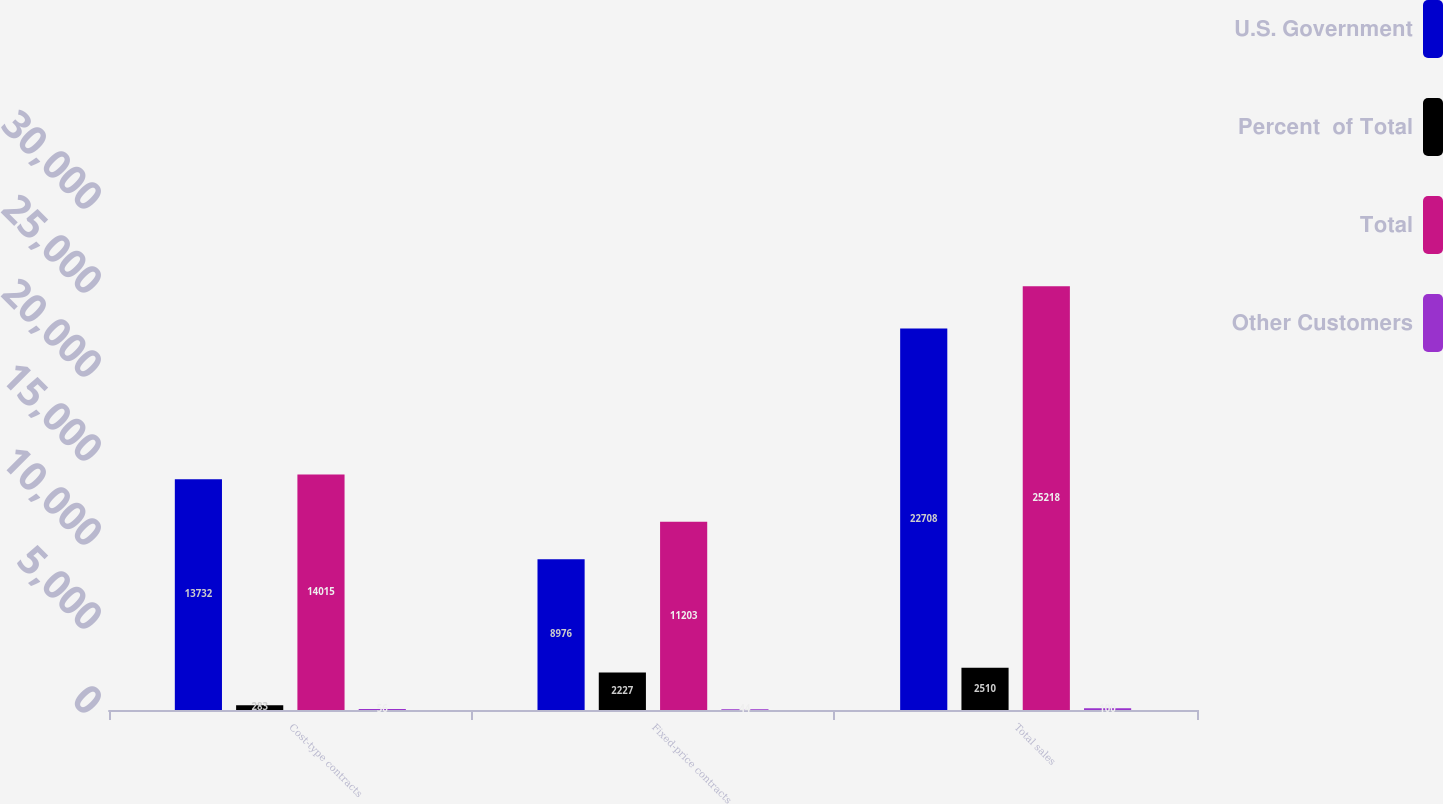<chart> <loc_0><loc_0><loc_500><loc_500><stacked_bar_chart><ecel><fcel>Cost-type contracts<fcel>Fixed-price contracts<fcel>Total sales<nl><fcel>U.S. Government<fcel>13732<fcel>8976<fcel>22708<nl><fcel>Percent  of Total<fcel>283<fcel>2227<fcel>2510<nl><fcel>Total<fcel>14015<fcel>11203<fcel>25218<nl><fcel>Other Customers<fcel>56<fcel>44<fcel>100<nl></chart> 